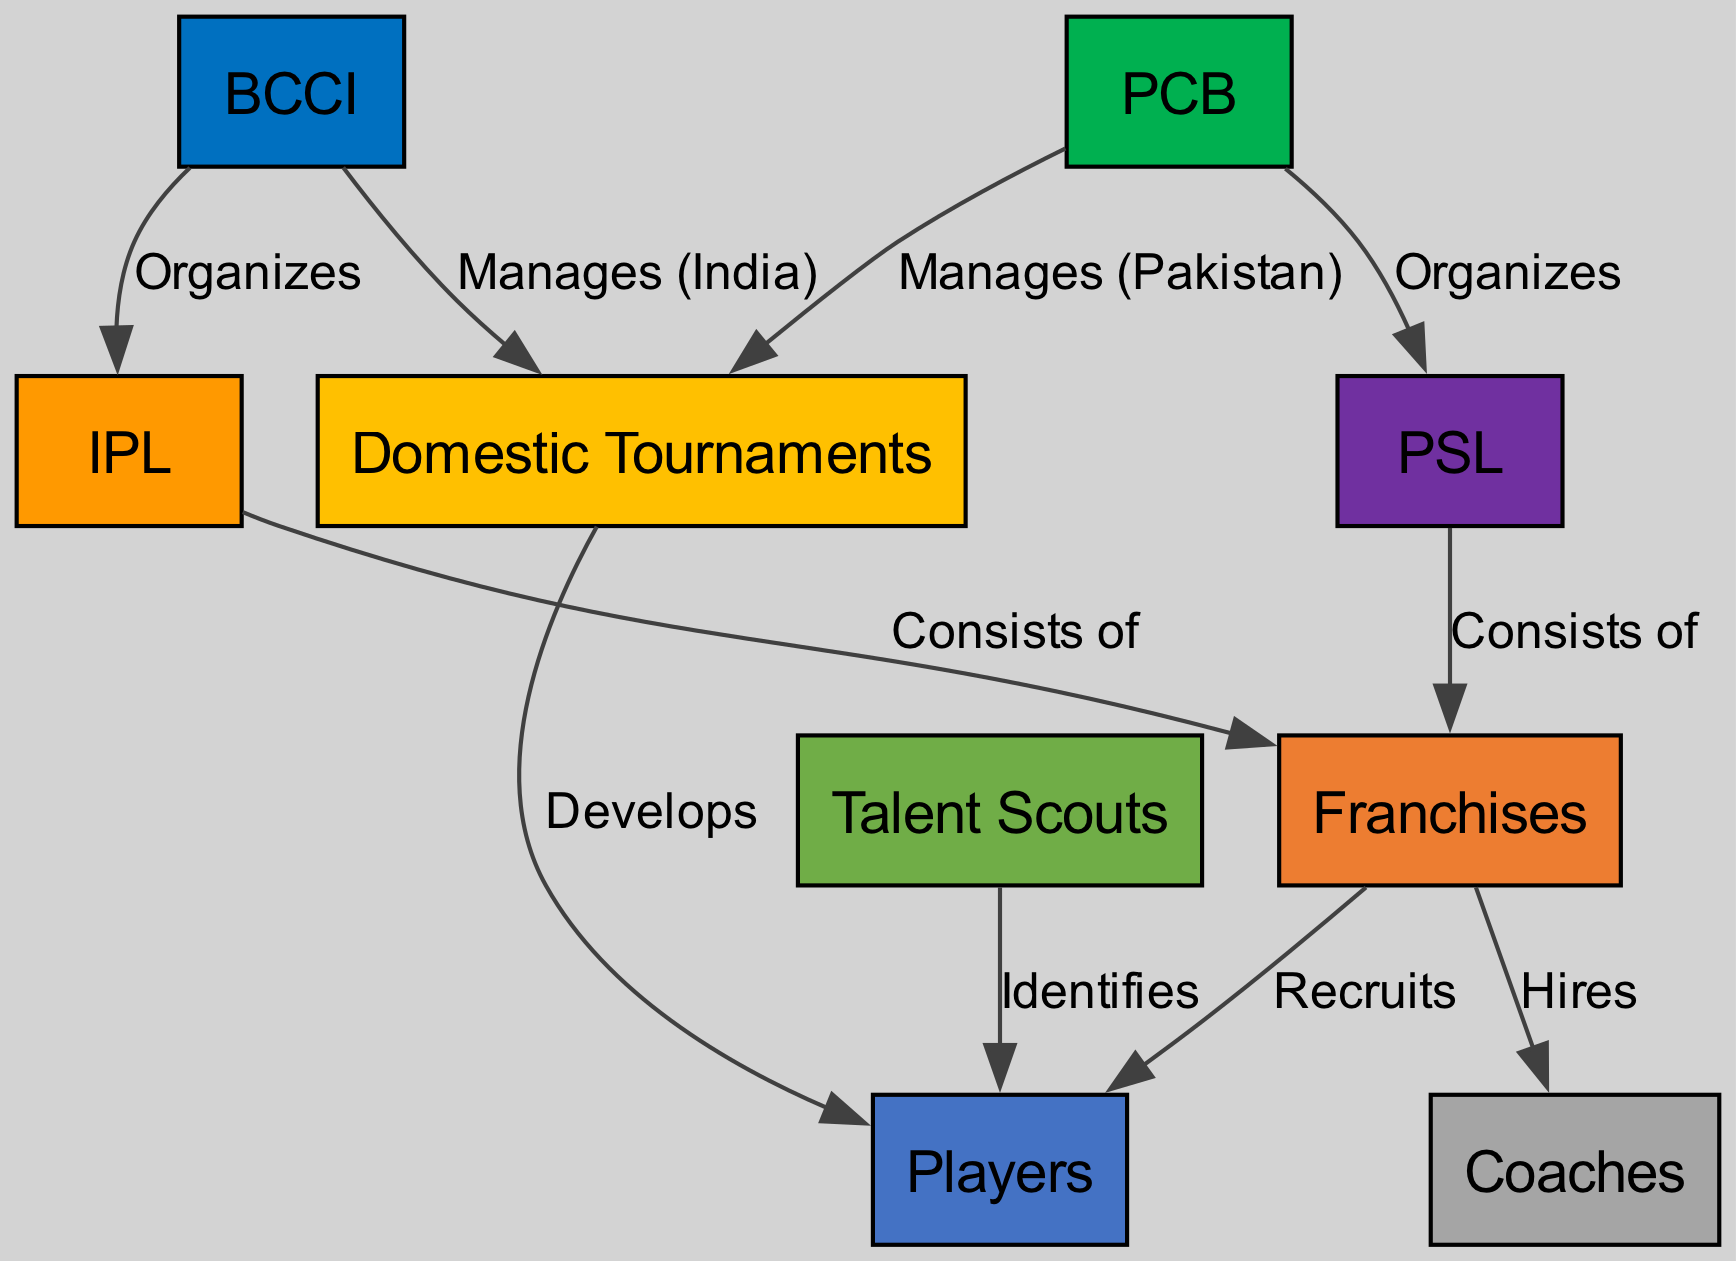What organization manages the IPL? The diagram indicates that the BCCI organizes the IPL, as there is a direct edge labeled "Organizes" connecting the BCCI node to the IPL node.
Answer: BCCI How many franchises are part of the IPL? The diagram shows that the IPL consists of the Franchises node, but it does not specify the number. Hence, this question would be looking for a descriptive count that cannot be directly answered based on the available data.
Answer: Not specified Who recruits players in the Franchises? According to the diagram, the Franchises node has an outgoing edge labeled "Recruits" pointing to the Players node, which indicates that they are responsible for recruiting players.
Answer: Franchises Which body manages domestic tournaments in Pakistan? The diagram displays that the PCB manages domestic tournaments in Pakistan, as indicated by the edge labeled "Manages (Pakistan)" pointing from PCB to Domestic Tournaments.
Answer: PCB What do talent scouts identify? The diagram shows an outgoing edge labeled "Identifies" from the Talent Scouts node to the Players node, suggesting that talent scouts are responsible for identifying players.
Answer: Players What are the primary leagues organized by BCCI and PCB? The diagram lists both IPL and PSL as the primary leagues organized by BCCI and PCB, respectively, as seen in the edges labeled "Organizes".
Answer: IPL and PSL Which node indicates the hiring of coaches? The diagram features an edge labeled "Hires" coming from the Franchises node to the Coaches node, signifying that franchises are responsible for hiring coaches.
Answer: Franchises How do domestic tournaments impact players in India? The diagram illustrates that domestic tournaments develop players in India through the edge labeled "Develops". This implies that domestic tournaments have a positive impact on player development.
Answer: Develops Which nodes connect to domestic tournaments? The diagram leads out two edges from the Domestic Tournaments node to the Players node, implying that both BCCI manages the domestic tournaments in India and that they develop players as a result.
Answer: Players, BCCI 